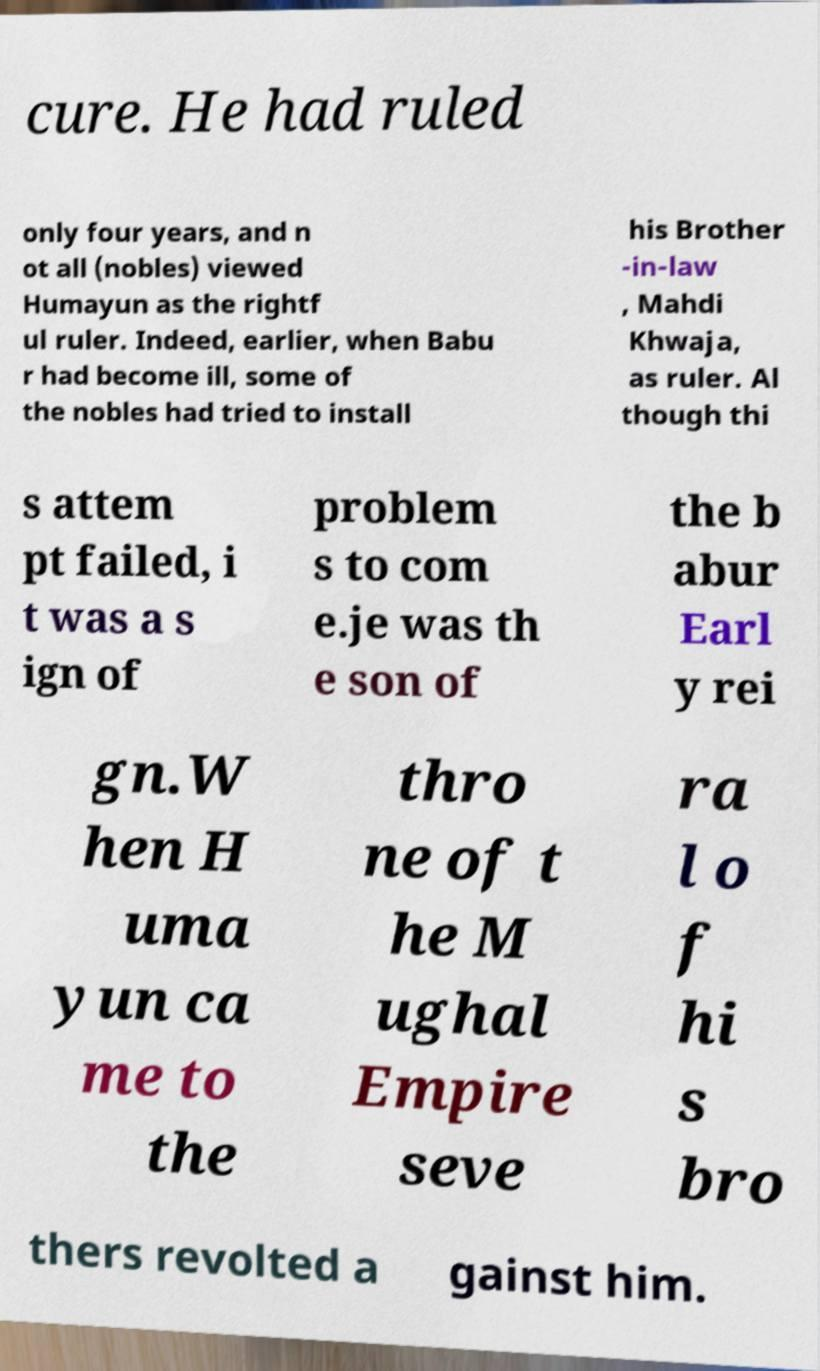Could you extract and type out the text from this image? cure. He had ruled only four years, and n ot all (nobles) viewed Humayun as the rightf ul ruler. Indeed, earlier, when Babu r had become ill, some of the nobles had tried to install his Brother -in-law , Mahdi Khwaja, as ruler. Al though thi s attem pt failed, i t was a s ign of problem s to com e.je was th e son of the b abur Earl y rei gn.W hen H uma yun ca me to the thro ne of t he M ughal Empire seve ra l o f hi s bro thers revolted a gainst him. 